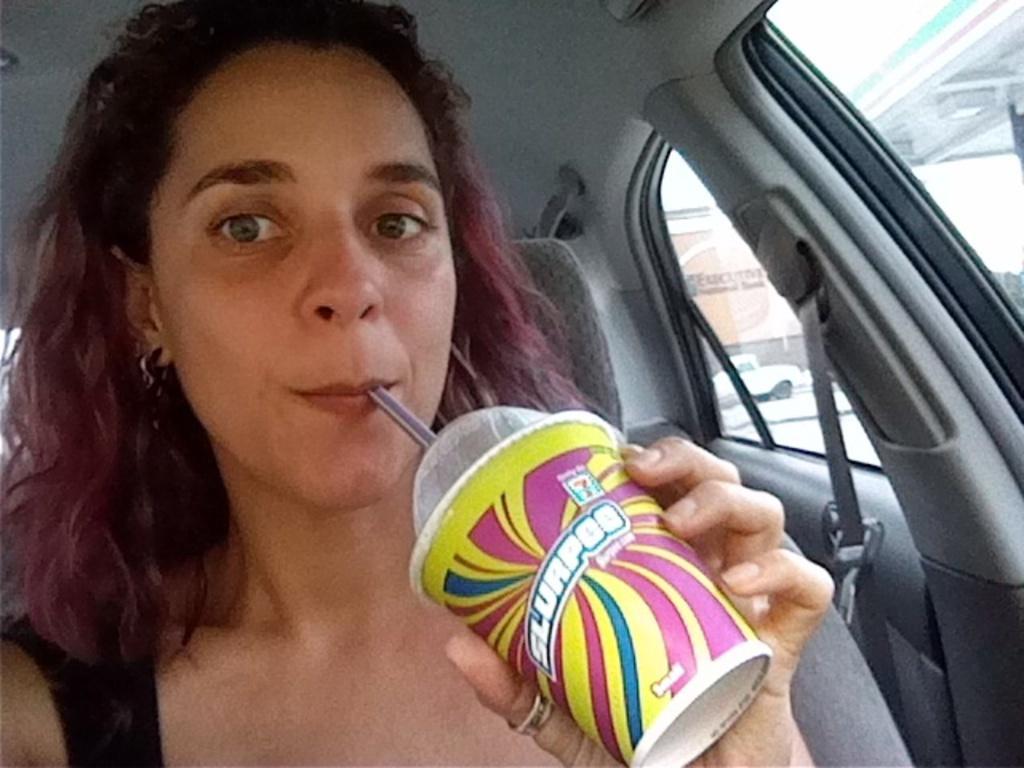In one or two sentences, can you explain what this image depicts? In this image we can see one woman sitting in the car, holding a cup and drinking. There is one car on the road, one building, some trees, one roof with black pole and at the top there is the sky. 